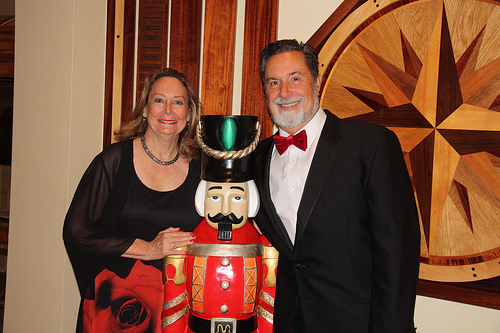<image>
Is the man next to the woman? Yes. The man is positioned adjacent to the woman, located nearby in the same general area. Is the sign next to the man? Yes. The sign is positioned adjacent to the man, located nearby in the same general area. Where is the nutcracker in relation to the man? Is it in front of the man? Yes. The nutcracker is positioned in front of the man, appearing closer to the camera viewpoint. 